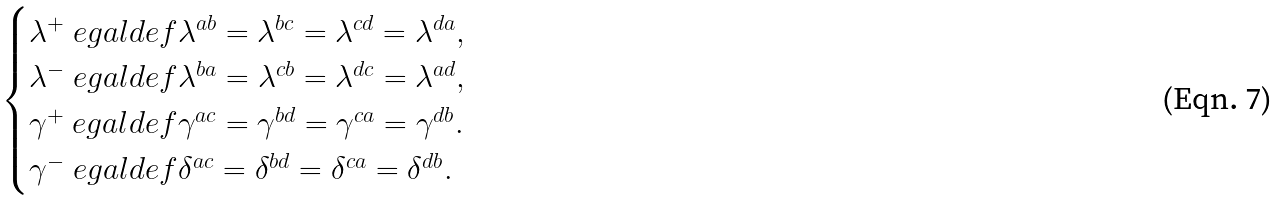<formula> <loc_0><loc_0><loc_500><loc_500>\begin{cases} \lambda ^ { + } \ e g a l d e f \lambda ^ { a b } = \lambda ^ { b c } = \lambda ^ { c d } = \lambda ^ { d a } , \\ \lambda ^ { - } \ e g a l d e f \lambda ^ { b a } = \lambda ^ { c b } = \lambda ^ { d c } = \lambda ^ { a d } , \\ \gamma ^ { + } \ e g a l d e f \gamma ^ { a c } = \gamma ^ { b d } = \gamma ^ { c a } = \gamma ^ { d b } . \\ \gamma ^ { - } \ e g a l d e f \delta ^ { a c } = \delta ^ { b d } = \delta ^ { c a } = \delta ^ { d b } . \end{cases}</formula> 